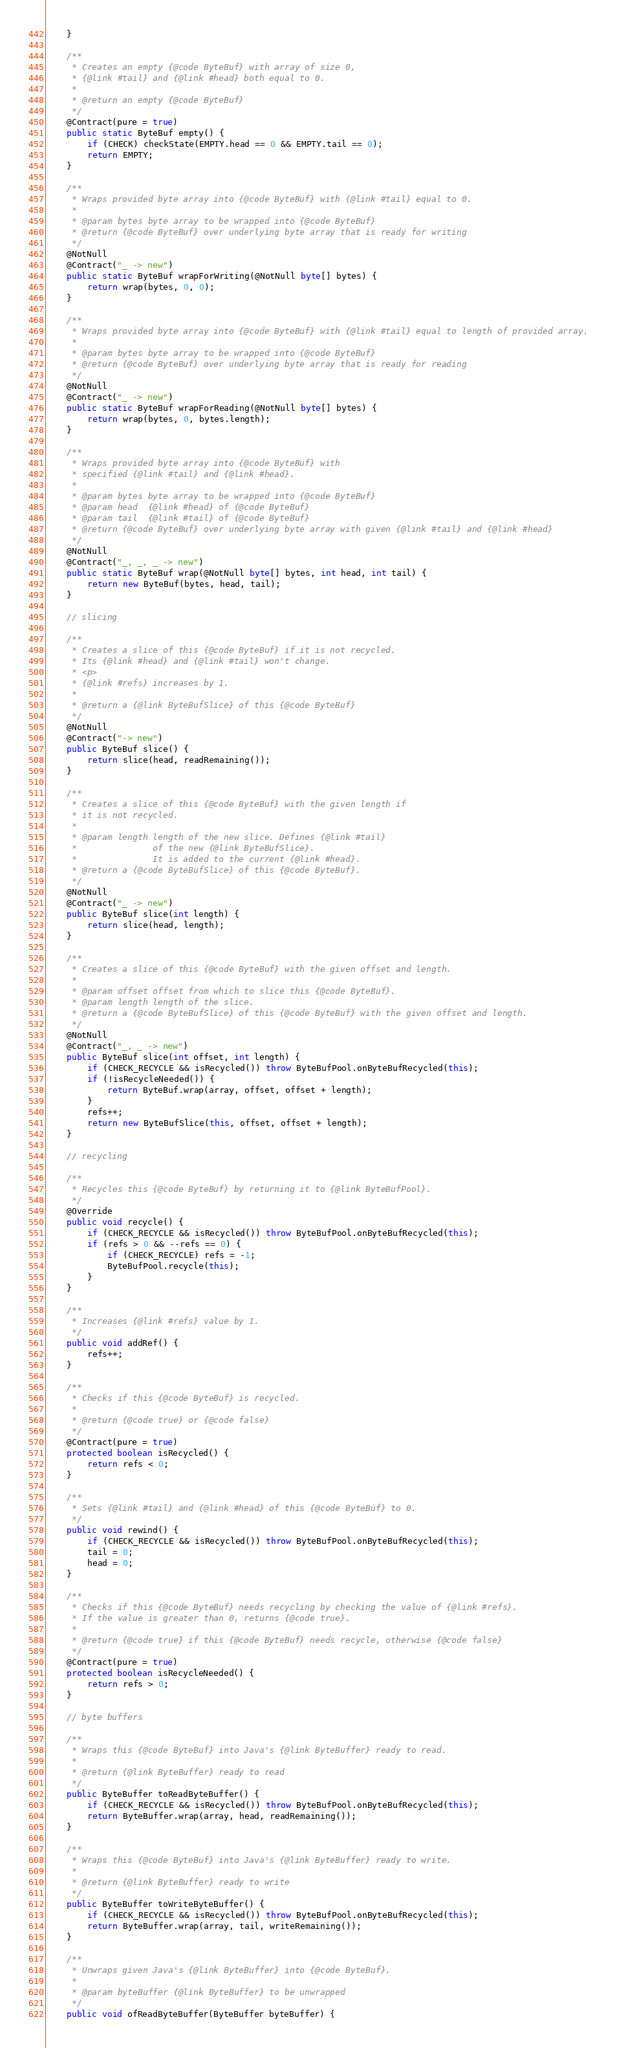Convert code to text. <code><loc_0><loc_0><loc_500><loc_500><_Java_>	}

	/**
	 * Creates an empty {@code ByteBuf} with array of size 0,
	 * {@link #tail} and {@link #head} both equal to 0.
	 *
	 * @return an empty {@code ByteBuf}
	 */
	@Contract(pure = true)
	public static ByteBuf empty() {
		if (CHECK) checkState(EMPTY.head == 0 && EMPTY.tail == 0);
		return EMPTY;
	}

	/**
	 * Wraps provided byte array into {@code ByteBuf} with {@link #tail} equal to 0.
	 *
	 * @param bytes byte array to be wrapped into {@code ByteBuf}
	 * @return {@code ByteBuf} over underlying byte array that is ready for writing
	 */
	@NotNull
	@Contract("_ -> new")
	public static ByteBuf wrapForWriting(@NotNull byte[] bytes) {
		return wrap(bytes, 0, 0);
	}

	/**
	 * Wraps provided byte array into {@code ByteBuf} with {@link #tail} equal to length of provided array.
	 *
	 * @param bytes byte array to be wrapped into {@code ByteBuf}
	 * @return {@code ByteBuf} over underlying byte array that is ready for reading
	 */
	@NotNull
	@Contract("_ -> new")
	public static ByteBuf wrapForReading(@NotNull byte[] bytes) {
		return wrap(bytes, 0, bytes.length);
	}

	/**
	 * Wraps provided byte array into {@code ByteBuf} with
	 * specified {@link #tail} and {@link #head}.
	 *
	 * @param bytes byte array to be wrapped into {@code ByteBuf}
	 * @param head  {@link #head} of {@code ByteBuf}
	 * @param tail  {@link #tail} of {@code ByteBuf}
	 * @return {@code ByteBuf} over underlying byte array with given {@link #tail} and {@link #head}
	 */
	@NotNull
	@Contract("_, _, _ -> new")
	public static ByteBuf wrap(@NotNull byte[] bytes, int head, int tail) {
		return new ByteBuf(bytes, head, tail);
	}

	// slicing

	/**
	 * Creates a slice of this {@code ByteBuf} if it is not recycled.
	 * Its {@link #head} and {@link #tail} won't change.
	 * <p>
	 * {@link #refs} increases by 1.
	 *
	 * @return a {@link ByteBufSlice} of this {@code ByteBuf}
	 */
	@NotNull
	@Contract("-> new")
	public ByteBuf slice() {
		return slice(head, readRemaining());
	}

	/**
	 * Creates a slice of this {@code ByteBuf} with the given length if
	 * it is not recycled.
	 *
	 * @param length length of the new slice. Defines {@link #tail}
	 *               of the new {@link ByteBufSlice}.
	 *               It is added to the current {@link #head}.
	 * @return a {@code ByteBufSlice} of this {@code ByteBuf}.
	 */
	@NotNull
	@Contract("_ -> new")
	public ByteBuf slice(int length) {
		return slice(head, length);
	}

	/**
	 * Creates a slice of this {@code ByteBuf} with the given offset and length.
	 *
	 * @param offset offset from which to slice this {@code ByteBuf}.
	 * @param length length of the slice.
	 * @return a {@code ByteBufSlice} of this {@code ByteBuf} with the given offset and length.
	 */
	@NotNull
	@Contract("_, _ -> new")
	public ByteBuf slice(int offset, int length) {
		if (CHECK_RECYCLE && isRecycled()) throw ByteBufPool.onByteBufRecycled(this);
		if (!isRecycleNeeded()) {
			return ByteBuf.wrap(array, offset, offset + length);
		}
		refs++;
		return new ByteBufSlice(this, offset, offset + length);
	}

	// recycling

	/**
	 * Recycles this {@code ByteBuf} by returning it to {@link ByteBufPool}.
	 */
	@Override
	public void recycle() {
		if (CHECK_RECYCLE && isRecycled()) throw ByteBufPool.onByteBufRecycled(this);
		if (refs > 0 && --refs == 0) {
			if (CHECK_RECYCLE) refs = -1;
			ByteBufPool.recycle(this);
		}
	}

	/**
	 * Increases {@link #refs} value by 1.
	 */
	public void addRef() {
		refs++;
	}

	/**
	 * Checks if this {@code ByteBuf} is recycled.
	 *
	 * @return {@code true} or {@code false}
	 */
	@Contract(pure = true)
	protected boolean isRecycled() {
		return refs < 0;
	}

	/**
	 * Sets {@link #tail} and {@link #head} of this {@code ByteBuf} to 0.
	 */
	public void rewind() {
		if (CHECK_RECYCLE && isRecycled()) throw ByteBufPool.onByteBufRecycled(this);
		tail = 0;
		head = 0;
	}

	/**
	 * Checks if this {@code ByteBuf} needs recycling by checking the value of {@link #refs}.
	 * If the value is greater than 0, returns {@code true}.
	 *
	 * @return {@code true} if this {@code ByteBuf} needs recycle, otherwise {@code false}
	 */
	@Contract(pure = true)
	protected boolean isRecycleNeeded() {
		return refs > 0;
	}

	// byte buffers

	/**
	 * Wraps this {@code ByteBuf} into Java's {@link ByteBuffer} ready to read.
	 *
	 * @return {@link ByteBuffer} ready to read
	 */
	public ByteBuffer toReadByteBuffer() {
		if (CHECK_RECYCLE && isRecycled()) throw ByteBufPool.onByteBufRecycled(this);
		return ByteBuffer.wrap(array, head, readRemaining());
	}

	/**
	 * Wraps this {@code ByteBuf} into Java's {@link ByteBuffer} ready to write.
	 *
	 * @return {@link ByteBuffer} ready to write
	 */
	public ByteBuffer toWriteByteBuffer() {
		if (CHECK_RECYCLE && isRecycled()) throw ByteBufPool.onByteBufRecycled(this);
		return ByteBuffer.wrap(array, tail, writeRemaining());
	}

	/**
	 * Unwraps given Java's {@link ByteBuffer} into {@code ByteBuf}.
	 *
	 * @param byteBuffer {@link ByteBuffer} to be unwrapped
	 */
	public void ofReadByteBuffer(ByteBuffer byteBuffer) {</code> 